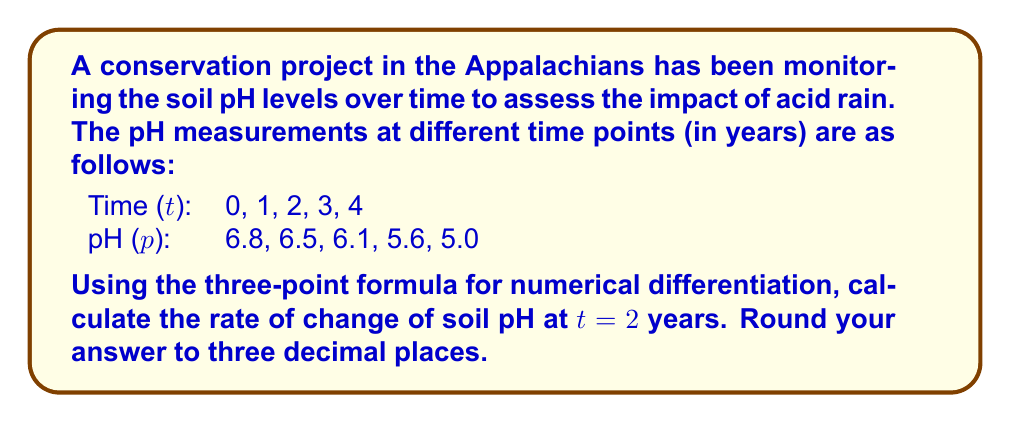Help me with this question. To solve this problem, we'll use the three-point formula for numerical differentiation:

$$f'(x) \approx \frac{f(x+h) - f(x-h)}{2h}$$

Where $h$ is the step size between data points.

Steps:
1. Identify the relevant data points:
   At t = 1: pH = 6.5
   At t = 2: pH = 6.1
   At t = 3: pH = 5.6

2. Set up the formula:
   $$\frac{dp}{dt}|_{t=2} \approx \frac{p(t+h) - p(t-h)}{2h}$$

3. Substitute the values:
   $h = 1$ (step size between time points)
   $p(t+h) = p(3) = 5.6$
   $p(t-h) = p(1) = 6.5$

   $$\frac{dp}{dt}|_{t=2} \approx \frac{5.6 - 6.5}{2(1)}$$

4. Calculate:
   $$\frac{dp}{dt}|_{t=2} \approx \frac{-0.9}{2} = -0.45$$

5. Round to three decimal places:
   $$\frac{dp}{dt}|_{t=2} \approx -0.450$$

The negative value indicates that the pH is decreasing over time, which is consistent with the effects of acid rain on soil pH.
Answer: $-0.450$ pH units per year 